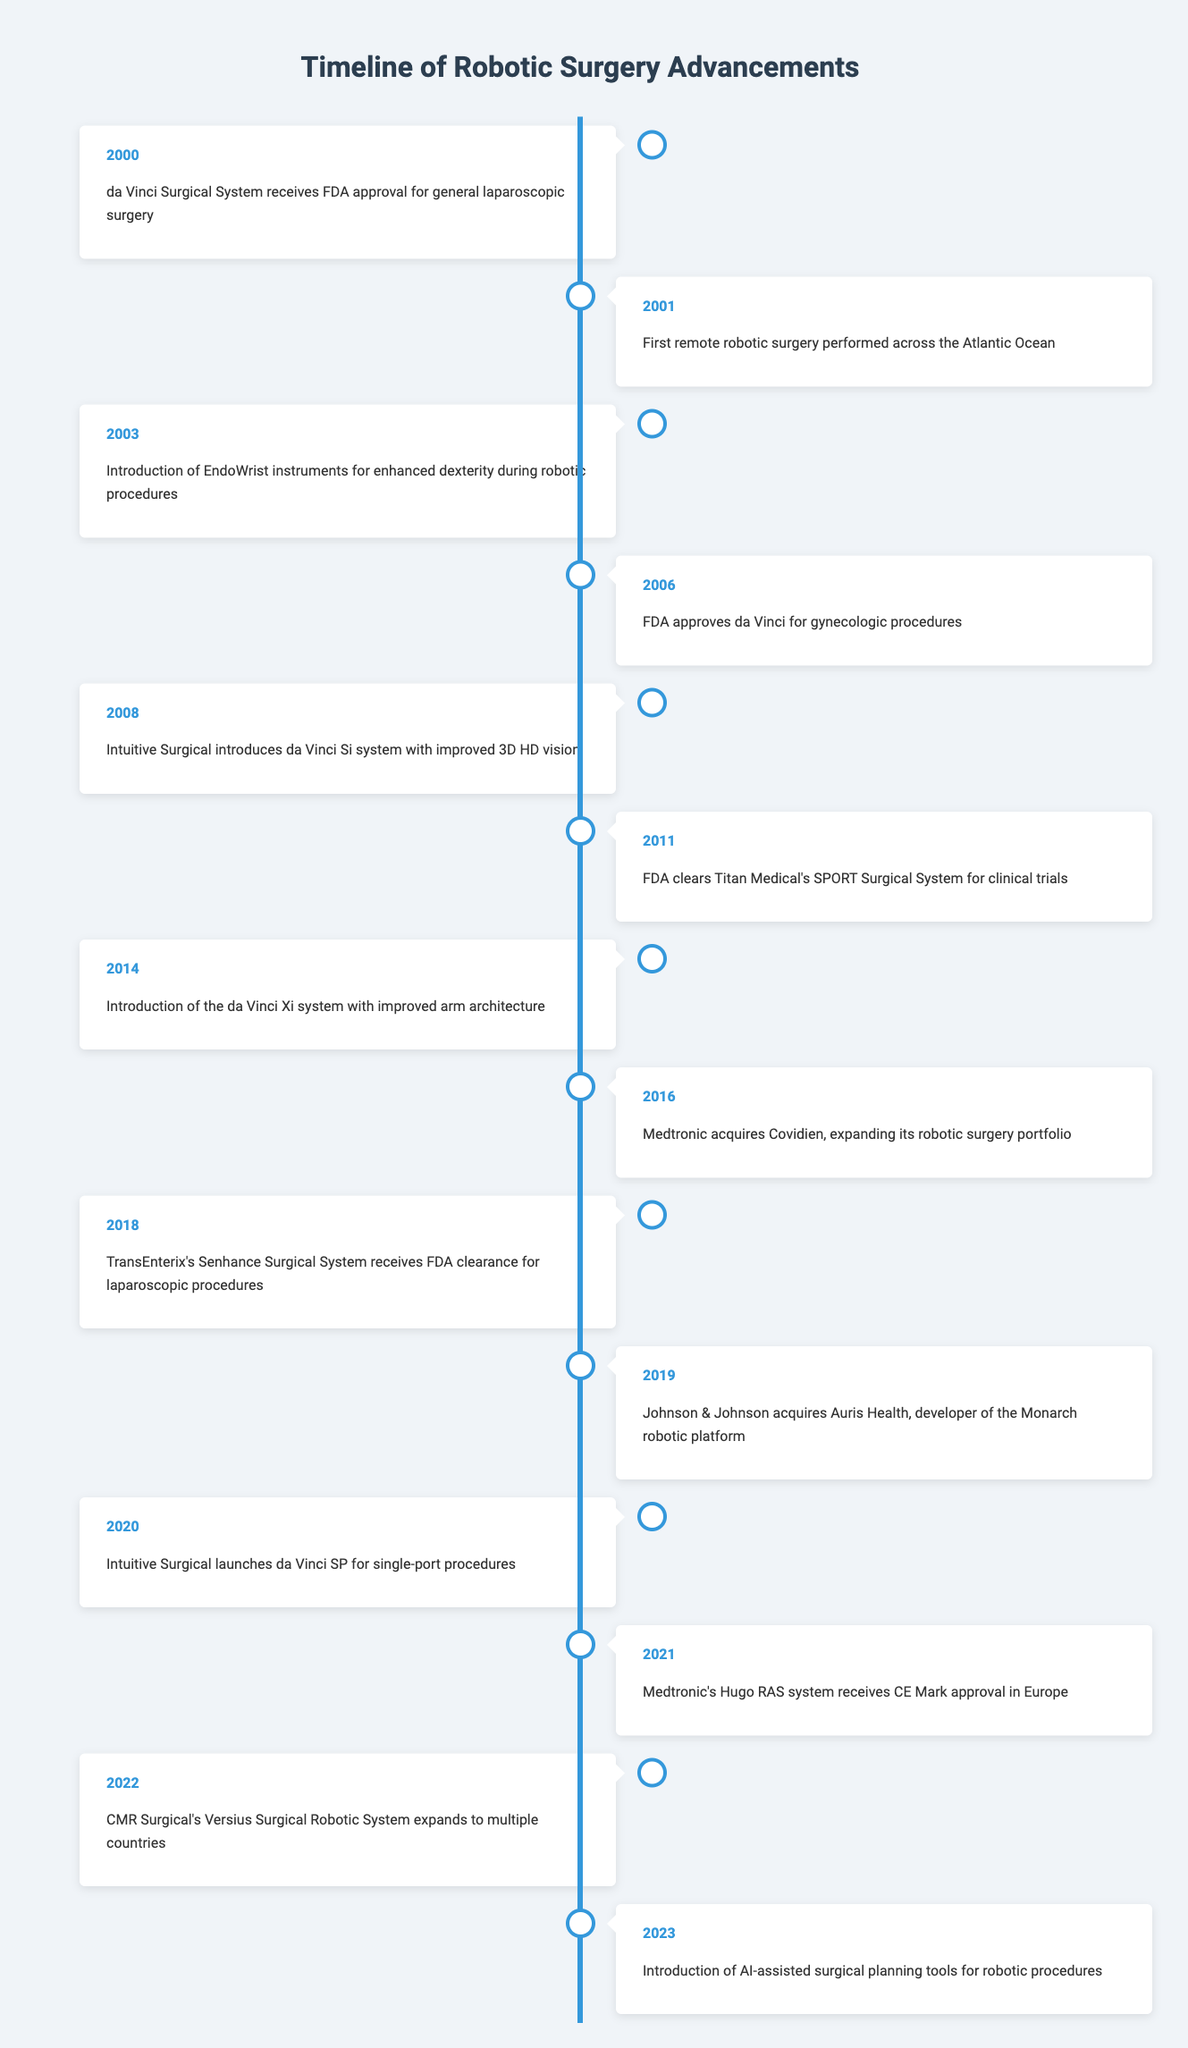What event occurred in the year 2000? The table clearly indicates that in 2000, the da Vinci Surgical System received FDA approval for general laparoscopic surgery.
Answer: da Vinci Surgical System receives FDA approval for general laparoscopic surgery Which system was introduced in 2008? According to the table, the system introduced in 2008 is the da Vinci Si system, which features improved 3D HD vision.
Answer: da Vinci Si system with improved 3D HD vision What was the first robotic surgery performed across the Atlantic Ocean? From the data, the event in 2001 states that the first remote robotic surgery was performed across the Atlantic Ocean.
Answer: First remote robotic surgery How many advancements were made between 2011 and 2021? The advancements listed from 2011 to 2021 include 2011 (Titan Medical's SPORT Surgical System), 2014 (da Vinci Xi system), 2016 (Medtronic acquires Covidien), and 2021 (Medtronic's Hugo RAS system). This totals 4 advancements.
Answer: 4 Did CMR Surgical's Versius Surgical Robotic System expand in 2022? The table confirms that in 2022, CMR Surgical's Versius Surgical Robotic System expanded to multiple countries, indicating a positive development.
Answer: Yes What are the advancements related to gynecologic procedures from the timeline? The entries in the timeline related to gynecologic procedures include the FDA approval of the da Vinci system in 2006, indicating its relevance in this area.
Answer: FDA approval in 2006 Which company made an acquisition in 2019 and what did they acquire? The timeline states that in 2019, Johnson & Johnson acquired Auris Health, which is the developer of the Monarch robotic platform.
Answer: Johnson & Johnson acquired Auris Health How many years passed between the introduction of the da Vinci Si system and the launch of the da Vinci SP? The da Vinci Si system was introduced in 2008 and the da Vinci SP was launched in 2020. The time span between these two advancements is 2020 - 2008, which equals 12 years.
Answer: 12 years What new feature was introduced in robotic surgery in 2023? The event for 2023 in the table indicates the introduction of AI-assisted surgical planning tools for robotic procedures, demonstrating a significant advancement in technology.
Answer: AI-assisted surgical planning tools 